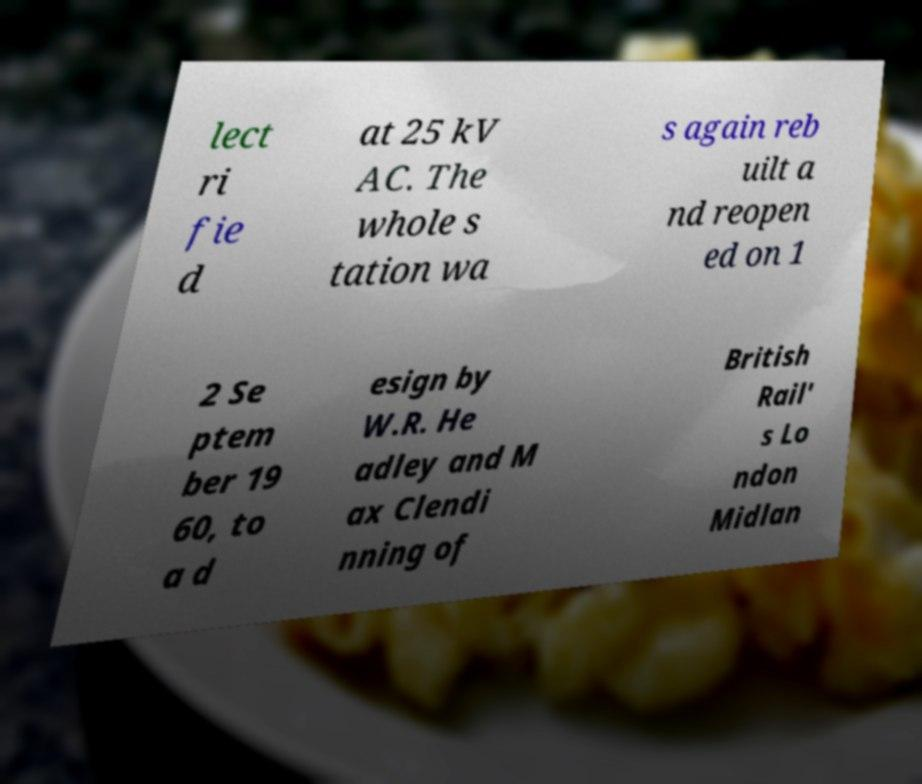What messages or text are displayed in this image? I need them in a readable, typed format. lect ri fie d at 25 kV AC. The whole s tation wa s again reb uilt a nd reopen ed on 1 2 Se ptem ber 19 60, to a d esign by W.R. He adley and M ax Clendi nning of British Rail' s Lo ndon Midlan 